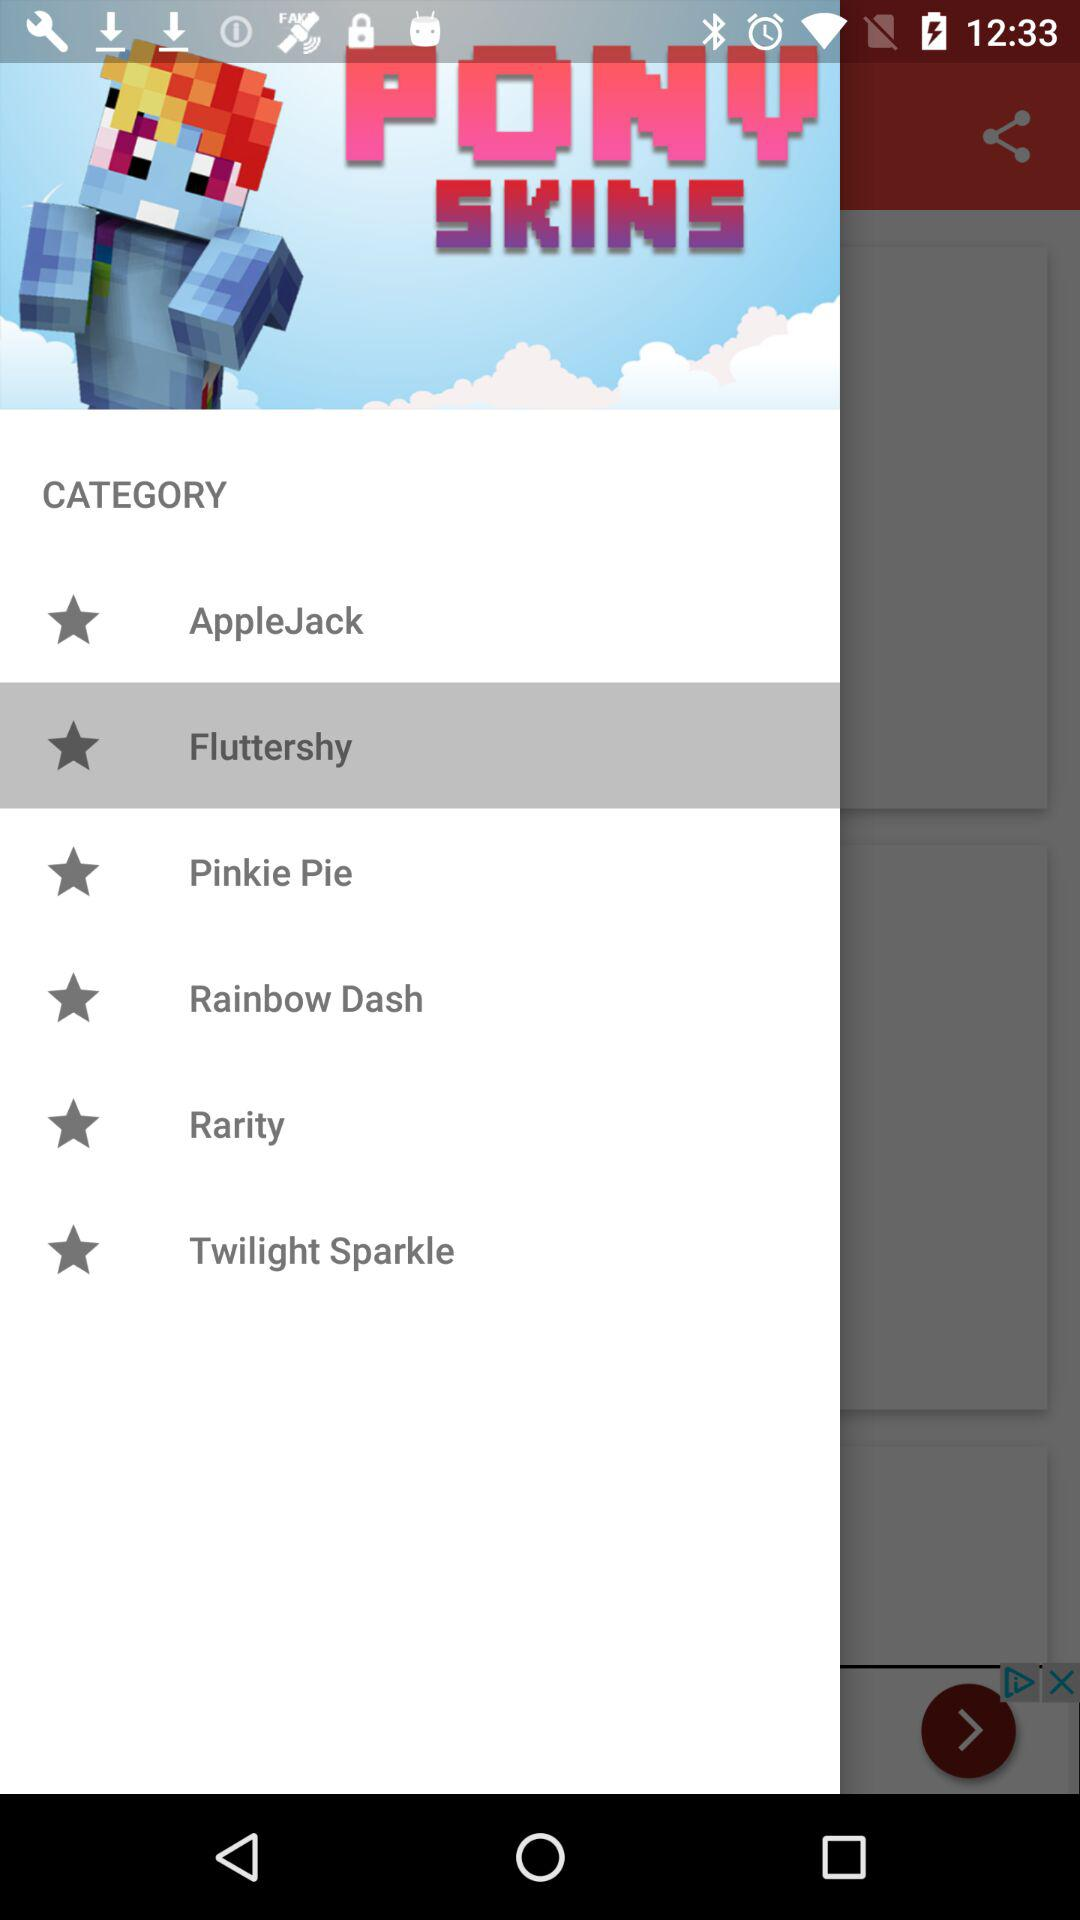How many pony skins are there?
Answer the question using a single word or phrase. 6 